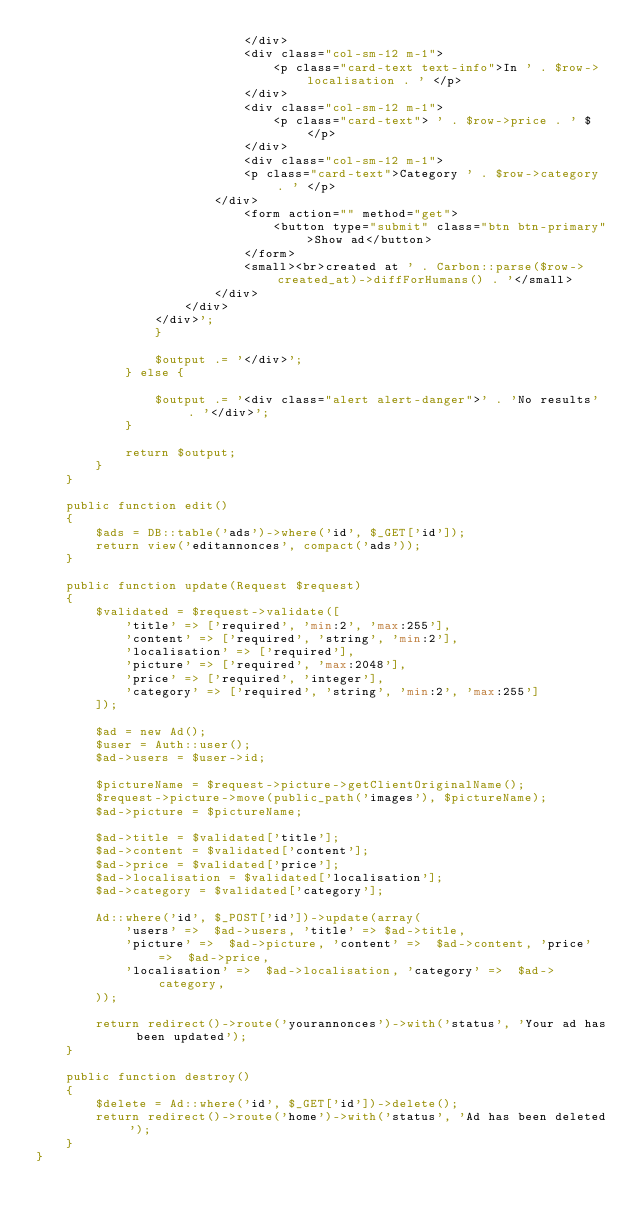<code> <loc_0><loc_0><loc_500><loc_500><_PHP_>                            </div>
                            <div class="col-sm-12 m-1">
                                <p class="card-text text-info">In ' . $row->localisation . ' </p>
                            </div>
                            <div class="col-sm-12 m-1">
                                <p class="card-text"> ' . $row->price . ' $ </p>
                            </div>
                            <div class="col-sm-12 m-1">
                            <p class="card-text">Category ' . $row->category . ' </p>
                        </div>
                            <form action="" method="get">
                                <button type="submit" class="btn btn-primary">Show ad</button>
                            </form>
                            <small><br>created at ' . Carbon::parse($row->created_at)->diffForHumans() . '</small>
                        </div>
                    </div>
                </div>';
                }

                $output .= '</div>';
            } else {

                $output .= '<div class="alert alert-danger">' . 'No results' . '</div>';
            }

            return $output;
        }
    }

    public function edit()
    {
        $ads = DB::table('ads')->where('id', $_GET['id']);
        return view('editannonces', compact('ads'));
    }

    public function update(Request $request)
    {
        $validated = $request->validate([
            'title' => ['required', 'min:2', 'max:255'],
            'content' => ['required', 'string', 'min:2'],
            'localisation' => ['required'],
            'picture' => ['required', 'max:2048'],
            'price' => ['required', 'integer'],
            'category' => ['required', 'string', 'min:2', 'max:255']
        ]);

        $ad = new Ad();
        $user = Auth::user();
        $ad->users = $user->id;

        $pictureName = $request->picture->getClientOriginalName();
        $request->picture->move(public_path('images'), $pictureName);
        $ad->picture = $pictureName;

        $ad->title = $validated['title'];
        $ad->content = $validated['content'];
        $ad->price = $validated['price'];
        $ad->localisation = $validated['localisation'];
        $ad->category = $validated['category'];

        Ad::where('id', $_POST['id'])->update(array(
            'users' =>  $ad->users, 'title' => $ad->title,
            'picture' =>  $ad->picture, 'content' =>  $ad->content, 'price' =>  $ad->price,
            'localisation' =>  $ad->localisation, 'category' =>  $ad->category,
        ));

        return redirect()->route('yourannonces')->with('status', 'Your ad has been updated');
    }

    public function destroy()
    {
        $delete = Ad::where('id', $_GET['id'])->delete();
        return redirect()->route('home')->with('status', 'Ad has been deleted');
    }
}
</code> 